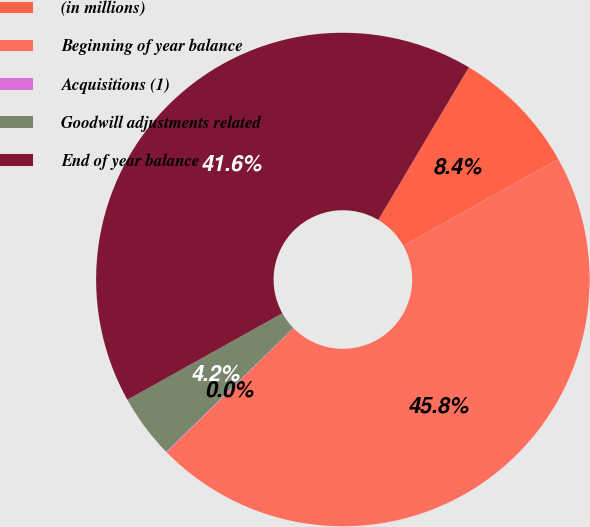Convert chart. <chart><loc_0><loc_0><loc_500><loc_500><pie_chart><fcel>(in millions)<fcel>Beginning of year balance<fcel>Acquisitions (1)<fcel>Goodwill adjustments related<fcel>End of year balance<nl><fcel>8.36%<fcel>45.77%<fcel>0.04%<fcel>4.2%<fcel>41.62%<nl></chart> 